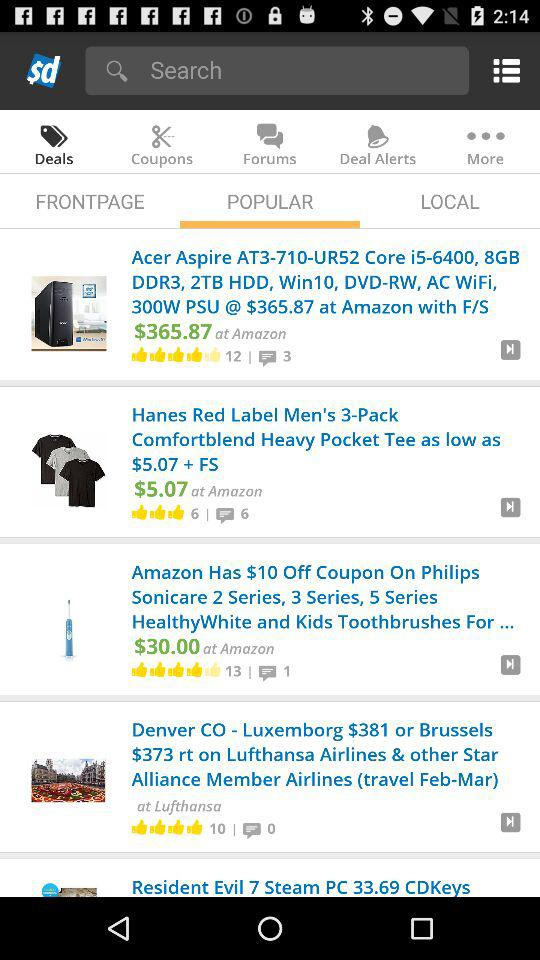Which item has the highest number of thumbs up? Amazon Has $10 Off Coupon On Philips Sonicare 2 Series, 3 Series, 5 Series HealthyWhite and Kids Toothbrushes For ... 